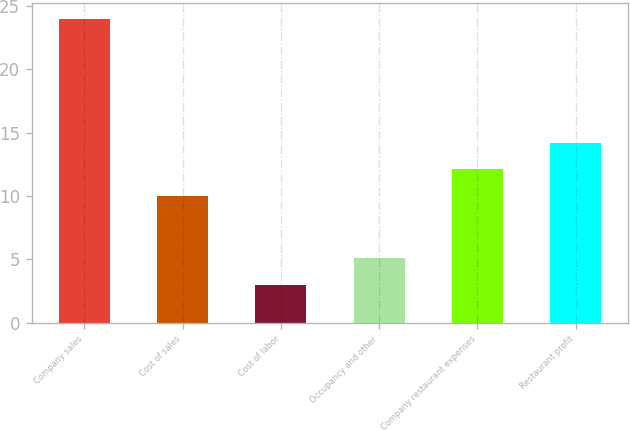Convert chart to OTSL. <chart><loc_0><loc_0><loc_500><loc_500><bar_chart><fcel>Company sales<fcel>Cost of sales<fcel>Cost of labor<fcel>Occupancy and other<fcel>Company restaurant expenses<fcel>Restaurant profit<nl><fcel>24<fcel>10<fcel>3<fcel>5.1<fcel>12.1<fcel>14.2<nl></chart> 